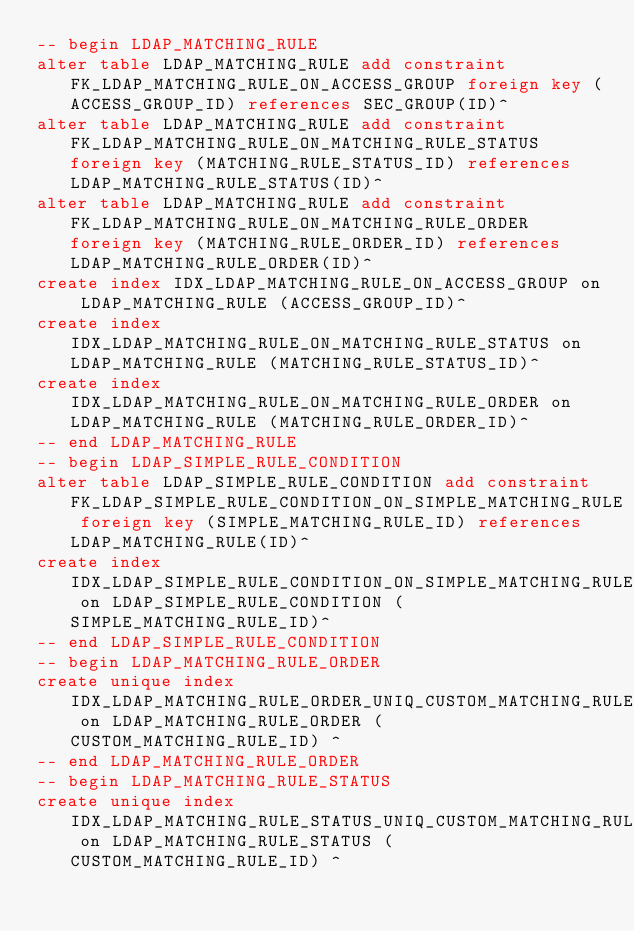<code> <loc_0><loc_0><loc_500><loc_500><_SQL_>-- begin LDAP_MATCHING_RULE
alter table LDAP_MATCHING_RULE add constraint FK_LDAP_MATCHING_RULE_ON_ACCESS_GROUP foreign key (ACCESS_GROUP_ID) references SEC_GROUP(ID)^
alter table LDAP_MATCHING_RULE add constraint FK_LDAP_MATCHING_RULE_ON_MATCHING_RULE_STATUS foreign key (MATCHING_RULE_STATUS_ID) references LDAP_MATCHING_RULE_STATUS(ID)^
alter table LDAP_MATCHING_RULE add constraint FK_LDAP_MATCHING_RULE_ON_MATCHING_RULE_ORDER foreign key (MATCHING_RULE_ORDER_ID) references LDAP_MATCHING_RULE_ORDER(ID)^
create index IDX_LDAP_MATCHING_RULE_ON_ACCESS_GROUP on LDAP_MATCHING_RULE (ACCESS_GROUP_ID)^
create index IDX_LDAP_MATCHING_RULE_ON_MATCHING_RULE_STATUS on LDAP_MATCHING_RULE (MATCHING_RULE_STATUS_ID)^
create index IDX_LDAP_MATCHING_RULE_ON_MATCHING_RULE_ORDER on LDAP_MATCHING_RULE (MATCHING_RULE_ORDER_ID)^
-- end LDAP_MATCHING_RULE
-- begin LDAP_SIMPLE_RULE_CONDITION
alter table LDAP_SIMPLE_RULE_CONDITION add constraint FK_LDAP_SIMPLE_RULE_CONDITION_ON_SIMPLE_MATCHING_RULE foreign key (SIMPLE_MATCHING_RULE_ID) references LDAP_MATCHING_RULE(ID)^
create index IDX_LDAP_SIMPLE_RULE_CONDITION_ON_SIMPLE_MATCHING_RULE on LDAP_SIMPLE_RULE_CONDITION (SIMPLE_MATCHING_RULE_ID)^
-- end LDAP_SIMPLE_RULE_CONDITION
-- begin LDAP_MATCHING_RULE_ORDER
create unique index IDX_LDAP_MATCHING_RULE_ORDER_UNIQ_CUSTOM_MATCHING_RULE_ID on LDAP_MATCHING_RULE_ORDER (CUSTOM_MATCHING_RULE_ID) ^
-- end LDAP_MATCHING_RULE_ORDER
-- begin LDAP_MATCHING_RULE_STATUS
create unique index IDX_LDAP_MATCHING_RULE_STATUS_UNIQ_CUSTOM_MATCHING_RULE_ID on LDAP_MATCHING_RULE_STATUS (CUSTOM_MATCHING_RULE_ID) ^</code> 